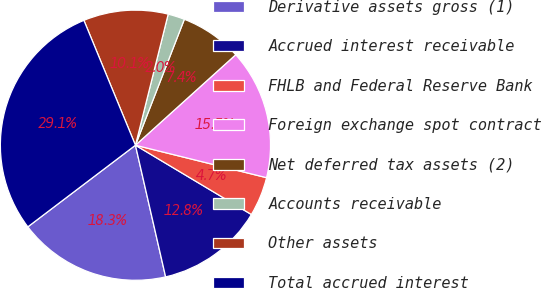Convert chart to OTSL. <chart><loc_0><loc_0><loc_500><loc_500><pie_chart><fcel>Derivative assets gross (1)<fcel>Accrued interest receivable<fcel>FHLB and Federal Reserve Bank<fcel>Foreign exchange spot contract<fcel>Net deferred tax assets (2)<fcel>Accounts receivable<fcel>Other assets<fcel>Total accrued interest<nl><fcel>18.26%<fcel>12.84%<fcel>4.71%<fcel>15.55%<fcel>7.42%<fcel>2.0%<fcel>10.13%<fcel>29.1%<nl></chart> 